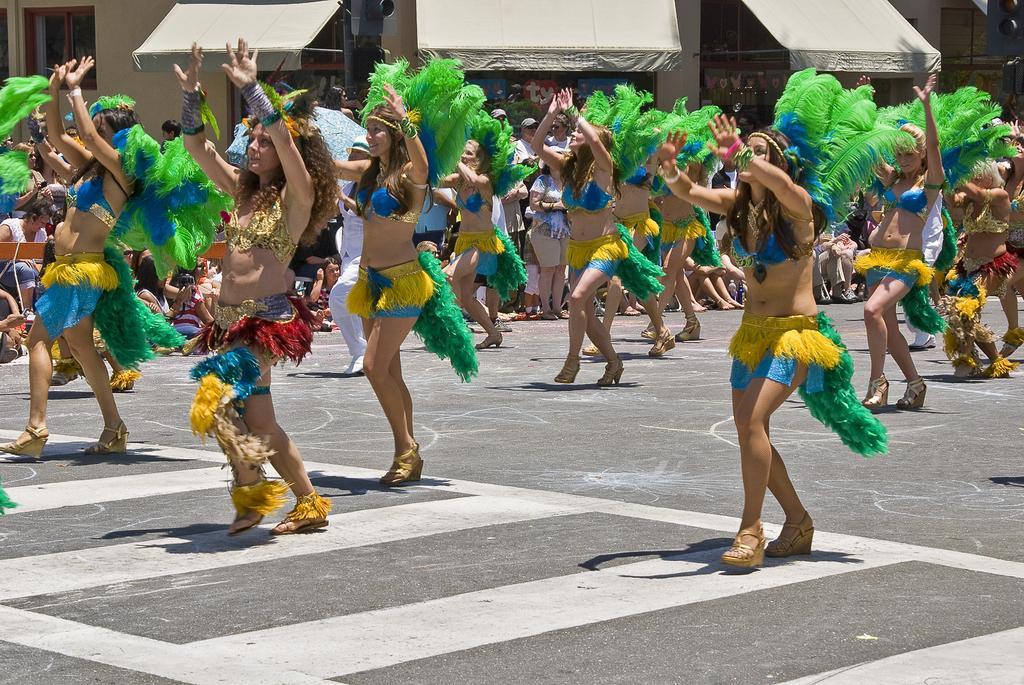Describe this image in one or two sentences. In this picture we can see a group of women dancing on the road, sunshades, building with windows and some people standing. 